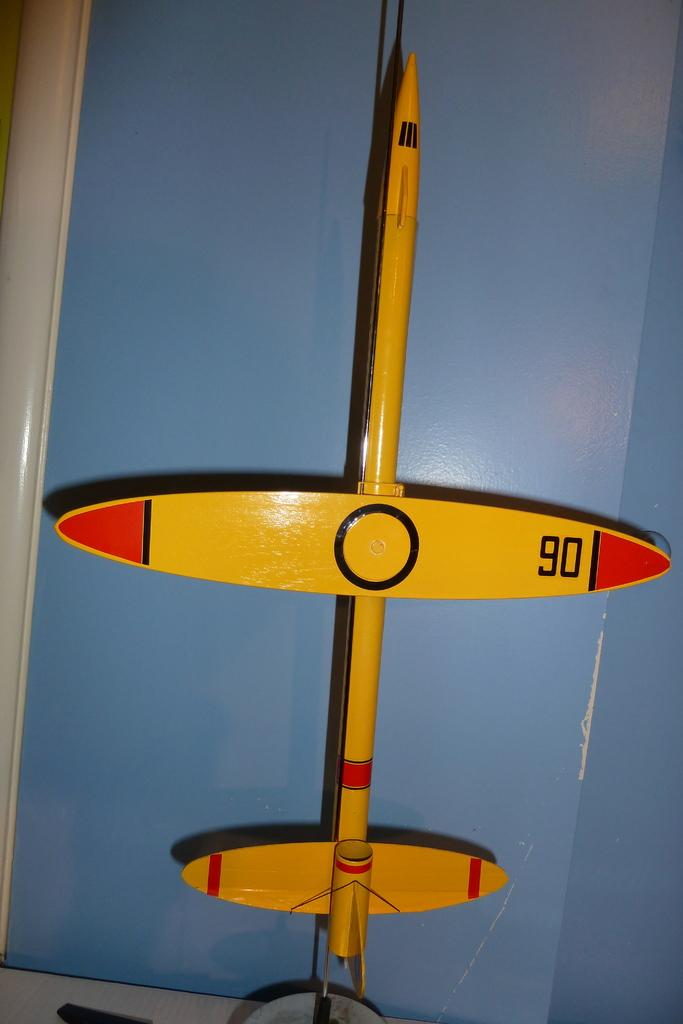What object can be seen in the image? There is a toy in the image. What colors are used for the toy? The toy is in yellow and red color. Can you see a rabbit playing with the toy in the image? There is no rabbit present in the image; it only features a toy in yellow and red color. Is there a hat on the toy in the image? The provided facts do not mention a hat on the toy, so we cannot determine its presence from the image. 